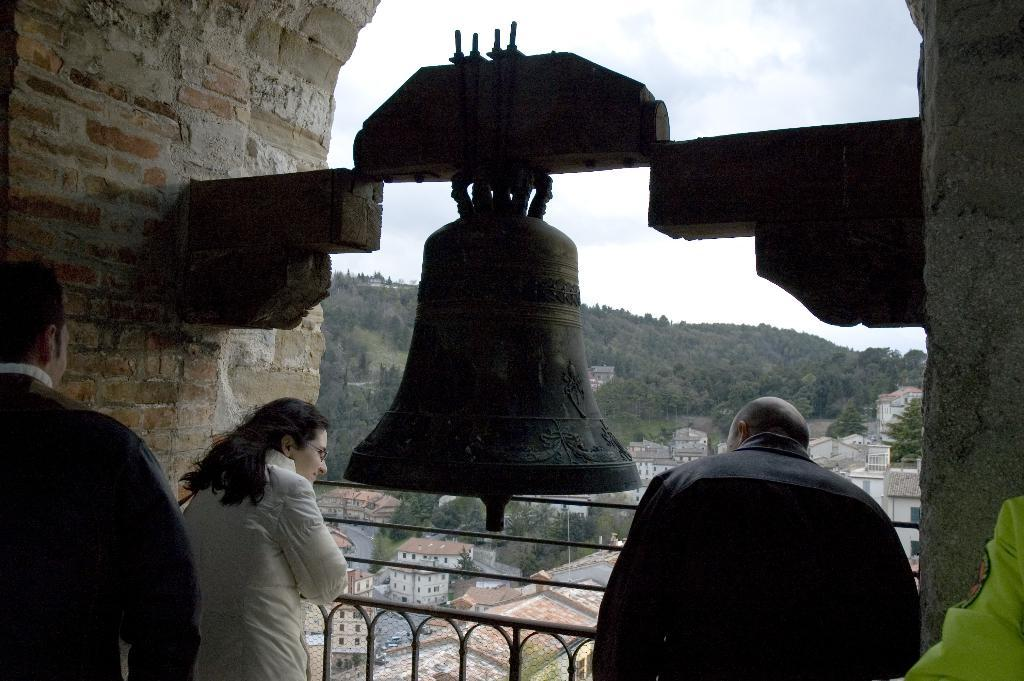How many people are present in the image? There are three people standing in the image. Can you describe the girl in the image? There is a girl in the image, but no specific details about her appearance are provided. What is located in the center of the image? There is a bell in the center of the image. What can be seen in the background of the image? There are buildings, trees, a hill, and the sky visible in the background of the image. What type of vegetable is being listed on the patch in the image? There is no vegetable or patch present in the image. Can you tell me how many items are on the list in the image? There is no list present in the image. 